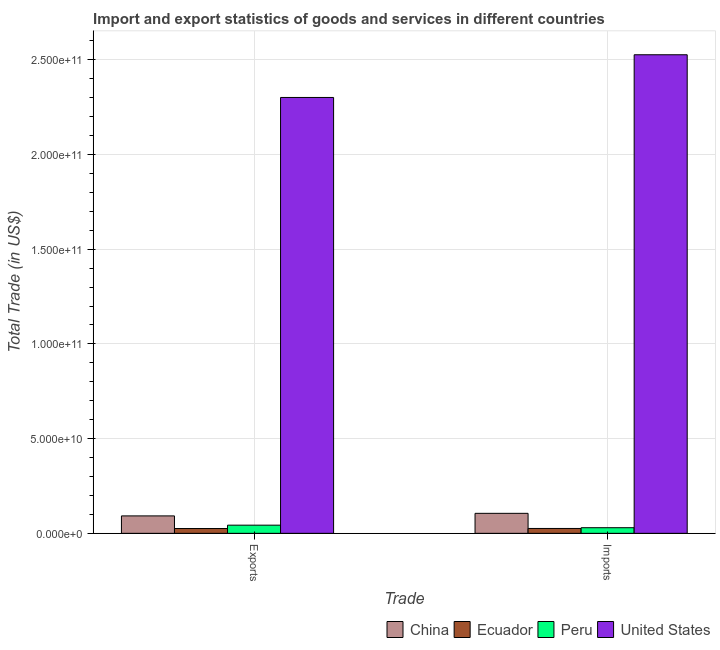How many different coloured bars are there?
Your response must be concise. 4. How many bars are there on the 1st tick from the left?
Ensure brevity in your answer.  4. How many bars are there on the 1st tick from the right?
Provide a succinct answer. 4. What is the label of the 1st group of bars from the left?
Offer a very short reply. Exports. What is the imports of goods and services in Peru?
Make the answer very short. 2.97e+09. Across all countries, what is the maximum imports of goods and services?
Provide a short and direct response. 2.53e+11. Across all countries, what is the minimum export of goods and services?
Offer a terse response. 2.54e+09. In which country was the imports of goods and services maximum?
Give a very brief answer. United States. In which country was the imports of goods and services minimum?
Your answer should be very brief. Ecuador. What is the total export of goods and services in the graph?
Keep it short and to the point. 2.46e+11. What is the difference between the imports of goods and services in United States and that in Peru?
Ensure brevity in your answer.  2.50e+11. What is the difference between the imports of goods and services in Ecuador and the export of goods and services in United States?
Keep it short and to the point. -2.28e+11. What is the average export of goods and services per country?
Your answer should be compact. 6.15e+1. What is the difference between the export of goods and services and imports of goods and services in Peru?
Make the answer very short. 1.34e+09. What is the ratio of the imports of goods and services in Ecuador to that in Peru?
Ensure brevity in your answer.  0.87. In how many countries, is the export of goods and services greater than the average export of goods and services taken over all countries?
Offer a very short reply. 1. What does the 3rd bar from the left in Imports represents?
Give a very brief answer. Peru. What does the 3rd bar from the right in Imports represents?
Ensure brevity in your answer.  Ecuador. How many bars are there?
Offer a very short reply. 8. Are all the bars in the graph horizontal?
Provide a succinct answer. No. How many countries are there in the graph?
Give a very brief answer. 4. Are the values on the major ticks of Y-axis written in scientific E-notation?
Provide a short and direct response. Yes. Does the graph contain grids?
Provide a short and direct response. Yes. What is the title of the graph?
Your answer should be compact. Import and export statistics of goods and services in different countries. What is the label or title of the X-axis?
Give a very brief answer. Trade. What is the label or title of the Y-axis?
Your answer should be very brief. Total Trade (in US$). What is the Total Trade (in US$) in China in Exports?
Offer a terse response. 9.20e+09. What is the Total Trade (in US$) in Ecuador in Exports?
Keep it short and to the point. 2.54e+09. What is the Total Trade (in US$) of Peru in Exports?
Your response must be concise. 4.31e+09. What is the Total Trade (in US$) of United States in Exports?
Keep it short and to the point. 2.30e+11. What is the Total Trade (in US$) of China in Imports?
Provide a short and direct response. 1.06e+1. What is the Total Trade (in US$) of Ecuador in Imports?
Ensure brevity in your answer.  2.58e+09. What is the Total Trade (in US$) in Peru in Imports?
Make the answer very short. 2.97e+09. What is the Total Trade (in US$) of United States in Imports?
Offer a very short reply. 2.53e+11. Across all Trade, what is the maximum Total Trade (in US$) of China?
Make the answer very short. 1.06e+1. Across all Trade, what is the maximum Total Trade (in US$) of Ecuador?
Provide a succinct answer. 2.58e+09. Across all Trade, what is the maximum Total Trade (in US$) in Peru?
Offer a very short reply. 4.31e+09. Across all Trade, what is the maximum Total Trade (in US$) in United States?
Provide a succinct answer. 2.53e+11. Across all Trade, what is the minimum Total Trade (in US$) of China?
Offer a terse response. 9.20e+09. Across all Trade, what is the minimum Total Trade (in US$) in Ecuador?
Provide a succinct answer. 2.54e+09. Across all Trade, what is the minimum Total Trade (in US$) in Peru?
Give a very brief answer. 2.97e+09. Across all Trade, what is the minimum Total Trade (in US$) of United States?
Offer a terse response. 2.30e+11. What is the total Total Trade (in US$) of China in the graph?
Offer a terse response. 1.98e+1. What is the total Total Trade (in US$) in Ecuador in the graph?
Make the answer very short. 5.11e+09. What is the total Total Trade (in US$) of Peru in the graph?
Your answer should be very brief. 7.28e+09. What is the total Total Trade (in US$) of United States in the graph?
Make the answer very short. 4.83e+11. What is the difference between the Total Trade (in US$) in China in Exports and that in Imports?
Ensure brevity in your answer.  -1.36e+09. What is the difference between the Total Trade (in US$) in Ecuador in Exports and that in Imports?
Your answer should be very brief. -3.73e+07. What is the difference between the Total Trade (in US$) of Peru in Exports and that in Imports?
Your answer should be compact. 1.34e+09. What is the difference between the Total Trade (in US$) of United States in Exports and that in Imports?
Make the answer very short. -2.25e+1. What is the difference between the Total Trade (in US$) in China in Exports and the Total Trade (in US$) in Ecuador in Imports?
Ensure brevity in your answer.  6.63e+09. What is the difference between the Total Trade (in US$) of China in Exports and the Total Trade (in US$) of Peru in Imports?
Ensure brevity in your answer.  6.24e+09. What is the difference between the Total Trade (in US$) in China in Exports and the Total Trade (in US$) in United States in Imports?
Provide a succinct answer. -2.43e+11. What is the difference between the Total Trade (in US$) in Ecuador in Exports and the Total Trade (in US$) in Peru in Imports?
Keep it short and to the point. -4.28e+08. What is the difference between the Total Trade (in US$) in Ecuador in Exports and the Total Trade (in US$) in United States in Imports?
Provide a succinct answer. -2.50e+11. What is the difference between the Total Trade (in US$) in Peru in Exports and the Total Trade (in US$) in United States in Imports?
Give a very brief answer. -2.48e+11. What is the average Total Trade (in US$) of China per Trade?
Offer a very short reply. 9.88e+09. What is the average Total Trade (in US$) of Ecuador per Trade?
Offer a terse response. 2.56e+09. What is the average Total Trade (in US$) in Peru per Trade?
Provide a succinct answer. 3.64e+09. What is the average Total Trade (in US$) of United States per Trade?
Provide a short and direct response. 2.41e+11. What is the difference between the Total Trade (in US$) in China and Total Trade (in US$) in Ecuador in Exports?
Your answer should be very brief. 6.67e+09. What is the difference between the Total Trade (in US$) of China and Total Trade (in US$) of Peru in Exports?
Your answer should be very brief. 4.89e+09. What is the difference between the Total Trade (in US$) in China and Total Trade (in US$) in United States in Exports?
Offer a terse response. -2.21e+11. What is the difference between the Total Trade (in US$) of Ecuador and Total Trade (in US$) of Peru in Exports?
Your answer should be very brief. -1.77e+09. What is the difference between the Total Trade (in US$) in Ecuador and Total Trade (in US$) in United States in Exports?
Your response must be concise. -2.28e+11. What is the difference between the Total Trade (in US$) in Peru and Total Trade (in US$) in United States in Exports?
Your response must be concise. -2.26e+11. What is the difference between the Total Trade (in US$) of China and Total Trade (in US$) of Ecuador in Imports?
Ensure brevity in your answer.  7.99e+09. What is the difference between the Total Trade (in US$) of China and Total Trade (in US$) of Peru in Imports?
Your answer should be very brief. 7.59e+09. What is the difference between the Total Trade (in US$) in China and Total Trade (in US$) in United States in Imports?
Offer a terse response. -2.42e+11. What is the difference between the Total Trade (in US$) in Ecuador and Total Trade (in US$) in Peru in Imports?
Provide a short and direct response. -3.91e+08. What is the difference between the Total Trade (in US$) in Ecuador and Total Trade (in US$) in United States in Imports?
Offer a very short reply. -2.50e+11. What is the difference between the Total Trade (in US$) of Peru and Total Trade (in US$) of United States in Imports?
Keep it short and to the point. -2.50e+11. What is the ratio of the Total Trade (in US$) in China in Exports to that in Imports?
Your response must be concise. 0.87. What is the ratio of the Total Trade (in US$) of Ecuador in Exports to that in Imports?
Offer a terse response. 0.99. What is the ratio of the Total Trade (in US$) of Peru in Exports to that in Imports?
Your response must be concise. 1.45. What is the ratio of the Total Trade (in US$) of United States in Exports to that in Imports?
Make the answer very short. 0.91. What is the difference between the highest and the second highest Total Trade (in US$) in China?
Give a very brief answer. 1.36e+09. What is the difference between the highest and the second highest Total Trade (in US$) in Ecuador?
Offer a very short reply. 3.73e+07. What is the difference between the highest and the second highest Total Trade (in US$) in Peru?
Your response must be concise. 1.34e+09. What is the difference between the highest and the second highest Total Trade (in US$) of United States?
Keep it short and to the point. 2.25e+1. What is the difference between the highest and the lowest Total Trade (in US$) of China?
Keep it short and to the point. 1.36e+09. What is the difference between the highest and the lowest Total Trade (in US$) of Ecuador?
Provide a succinct answer. 3.73e+07. What is the difference between the highest and the lowest Total Trade (in US$) in Peru?
Your answer should be very brief. 1.34e+09. What is the difference between the highest and the lowest Total Trade (in US$) in United States?
Your answer should be very brief. 2.25e+1. 